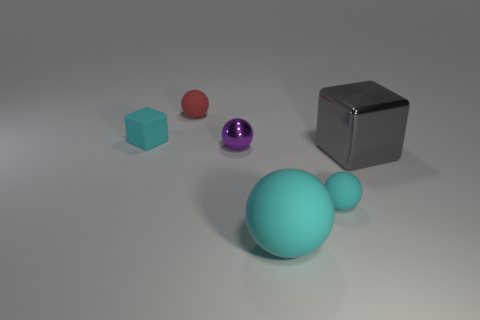If these objects were part of a game, what kind of game could it be? If these items were components of a game, it could potentially be a physics-based puzzle or educational game. The variation in shapes and materials suggests a setup where one could learn about geometry, material properties, or even engage in challenges that require sorting or placing the objects based on certain criteria or rules. 